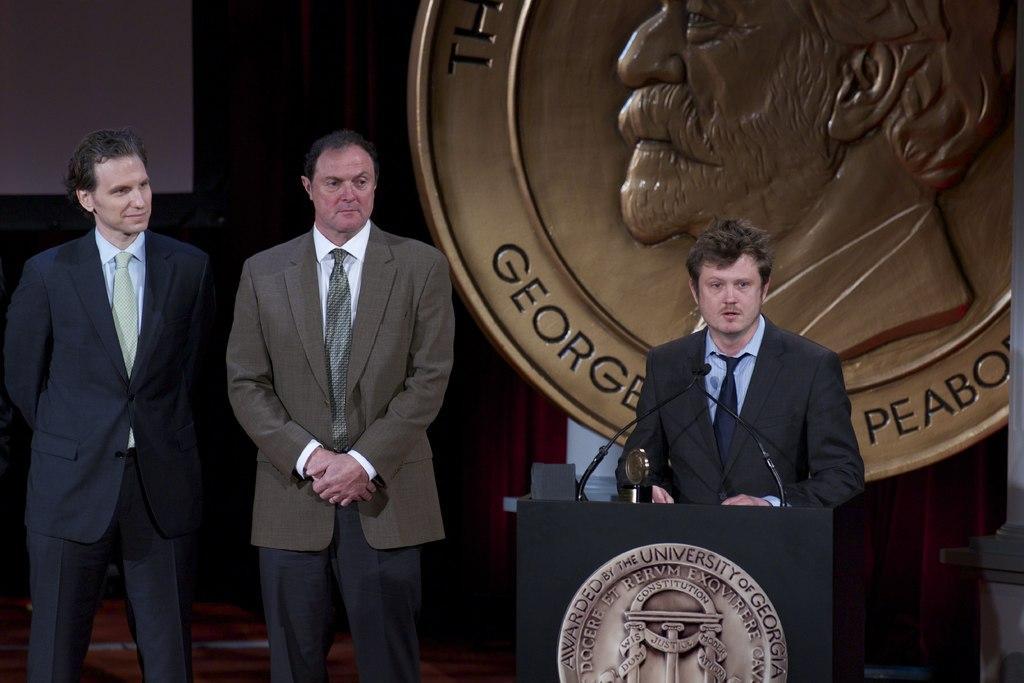Describe this image in one or two sentences. In the background we can see a large coin and there is a person. We can see a man standing near to a podium. On the podium we can see a mike and an object. Behind to him we can see man standing. 